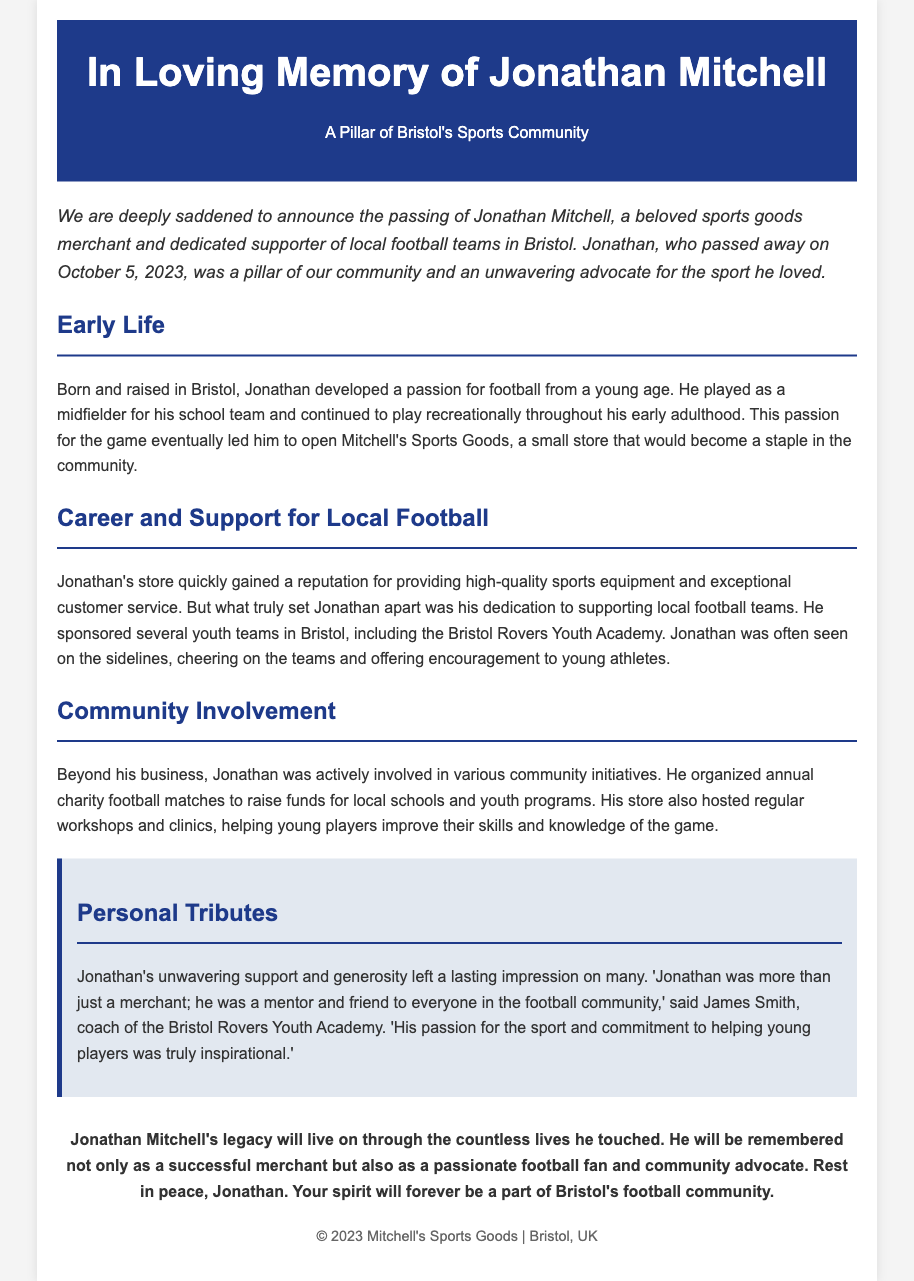what is the name of the sports goods merchant? The document mentions Jonathan Mitchell as the sports goods merchant.
Answer: Jonathan Mitchell when did Jonathan Mitchell pass away? The obituary states that Jonathan passed away on October 5, 2023.
Answer: October 5, 2023 what was the name of Jonathan's sports goods store? The document refers to the store he opened as Mitchell's Sports Goods.
Answer: Mitchell's Sports Goods which youth team did Jonathan sponsor? According to the document, he sponsored the Bristol Rovers Youth Academy.
Answer: Bristol Rovers Youth Academy what was Jonathan's role in football during his school years? The document indicates that he played as a midfielder for his school team.
Answer: Midfielder how did Jonathan contribute to the community? The obituary describes his organization of annual charity football matches for local schools and youth programs.
Answer: Annual charity football matches who described Jonathan as a mentor and friend? James Smith, the coach of the Bristol Rovers Youth Academy, is quoted as saying this about Jonathan.
Answer: James Smith what aspect of Jonathan's character is highlighted in the personal tributes? The tributes emphasize Jonathan’s passion for the sport and commitment to helping young players.
Answer: Passion and commitment how does the document conclude regarding Jonathan's legacy? The document concludes that his legacy will live on through the countless lives he touched.
Answer: Lives he touched 